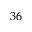Convert formula to latex. <formula><loc_0><loc_0><loc_500><loc_500>3 6</formula> 